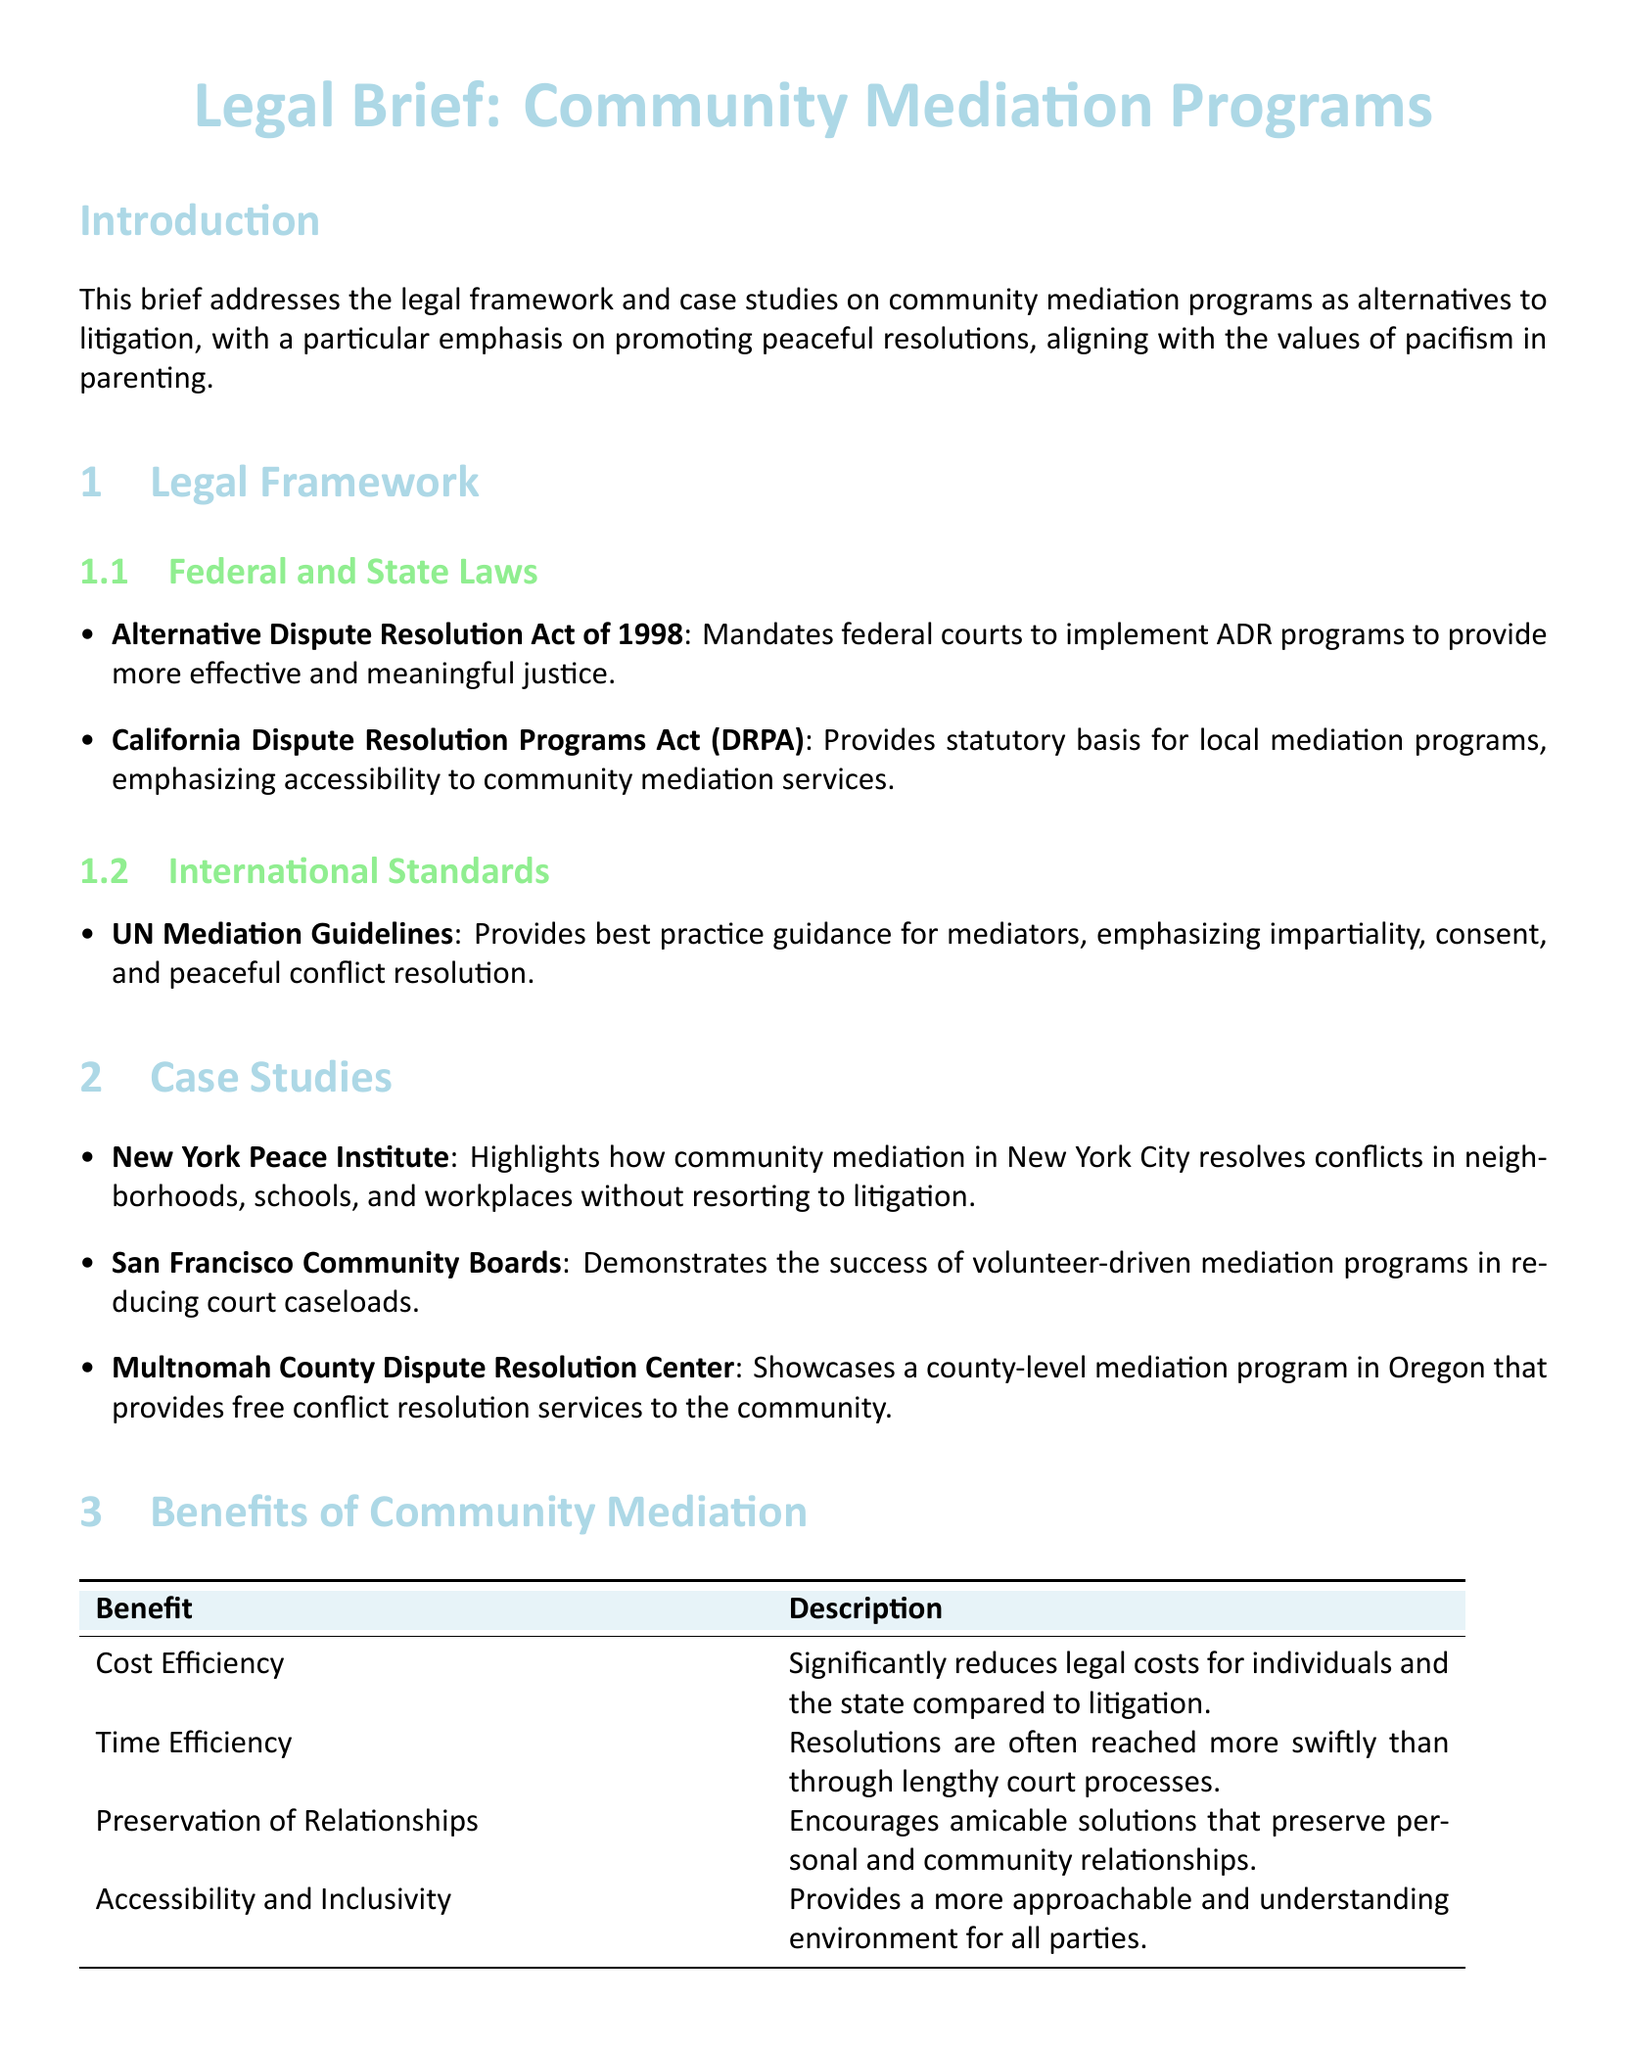What is the title of the legal brief? The title is provided at the beginning of the document, summarizing its focus on community mediation programs.
Answer: Legal Brief: Community Mediation Programs What act mandates federal courts to implement ADR programs? This information is found under the federal laws section.
Answer: Alternative Dispute Resolution Act of 1998 Which state has a Dispute Resolution Programs Act? This is mentioned in the section discussing state laws.
Answer: California What organization is highlighted for community mediation in New York City? This is listed in the case studies section of the document.
Answer: New York Peace Institute What is one benefit of community mediation mentioned? The benefits are outlined in a table in the document.
Answer: Cost Efficiency How do community mediation programs compare to litigation in terms of resolution time? This comparison is discussed in the benefits of mediation section.
Answer: More swiftly What aspect do the UN Mediation Guidelines emphasize? This information is found in the international standards subsection.
Answer: Impartiality What type of document is this? The document's purpose and format are indicated at the start.
Answer: Legal brief What year was the Alternative Dispute Resolution Act enacted? This year is presented alongside the name of the act in the legal framework section.
Answer: 1998 